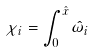Convert formula to latex. <formula><loc_0><loc_0><loc_500><loc_500>\chi _ { i } = \int _ { 0 } ^ { \hat { x } } \hat { \omega } _ { i }</formula> 